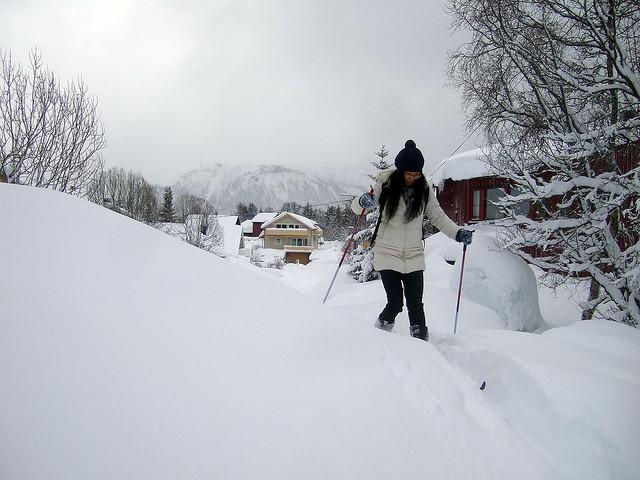Where is the dark neck warmer?
Give a very brief answer. Neck. What season is it?
Short answer required. Winter. Was this photo taken on a roadside?
Write a very short answer. No. What kind of trees are in the background?
Concise answer only. Pine. How is the person commuting in this photo?
Give a very brief answer. Skiing. What color do you notice?
Concise answer only. White. What is that object in the far background?
Write a very short answer. House. 